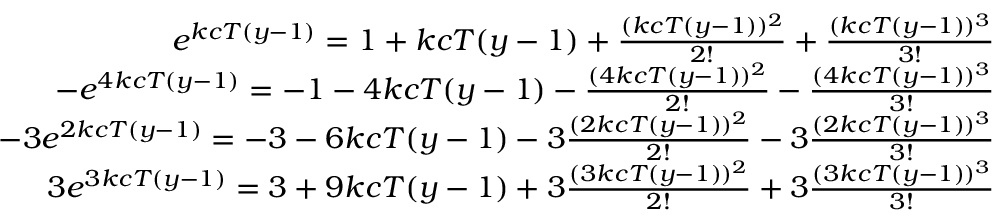Convert formula to latex. <formula><loc_0><loc_0><loc_500><loc_500>\begin{array} { r } { e ^ { k c T ( y - 1 ) } = 1 + k c T ( y - 1 ) + \frac { ( k c T ( y - 1 ) ) ^ { 2 } } { 2 ! } + \frac { ( k c T ( y - 1 ) ) ^ { 3 } } { 3 ! } } \\ { - e ^ { 4 k c T ( y - 1 ) } = - 1 - 4 k c T ( y - 1 ) - \frac { ( 4 k c T ( y - 1 ) ) ^ { 2 } } { 2 ! } - \frac { ( 4 k c T ( y - 1 ) ) ^ { 3 } } { 3 ! } } \\ { - 3 e ^ { 2 k c T ( y - 1 ) } = - 3 - 6 k c T ( y - 1 ) - 3 \frac { ( 2 k c T ( y - 1 ) ) ^ { 2 } } { 2 ! } - 3 \frac { ( 2 k c T ( y - 1 ) ) ^ { 3 } } { 3 ! } } \\ { 3 e ^ { 3 k c T ( y - 1 ) } = 3 + 9 k c T ( y - 1 ) + 3 \frac { ( 3 k c T ( y - 1 ) ) ^ { 2 } } { 2 ! } + 3 \frac { ( 3 k c T ( y - 1 ) ) ^ { 3 } } { 3 ! } } \end{array}</formula> 